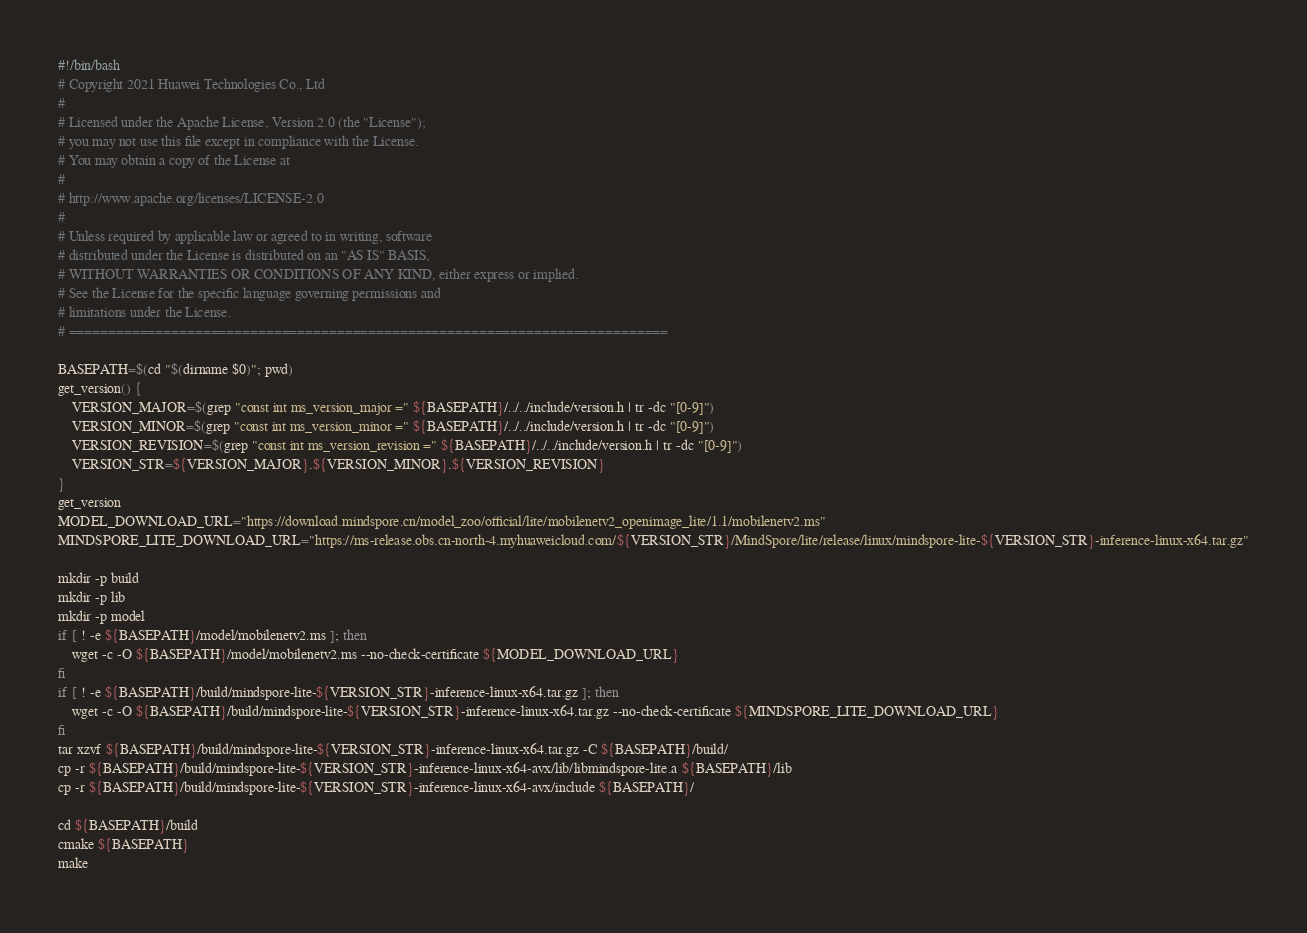<code> <loc_0><loc_0><loc_500><loc_500><_Bash_>#!/bin/bash
# Copyright 2021 Huawei Technologies Co., Ltd
#
# Licensed under the Apache License, Version 2.0 (the "License");
# you may not use this file except in compliance with the License.
# You may obtain a copy of the License at
#
# http://www.apache.org/licenses/LICENSE-2.0
#
# Unless required by applicable law or agreed to in writing, software
# distributed under the License is distributed on an "AS IS" BASIS,
# WITHOUT WARRANTIES OR CONDITIONS OF ANY KIND, either express or implied.
# See the License for the specific language governing permissions and
# limitations under the License.
# ============================================================================

BASEPATH=$(cd "$(dirname $0)"; pwd)
get_version() {
    VERSION_MAJOR=$(grep "const int ms_version_major =" ${BASEPATH}/../../include/version.h | tr -dc "[0-9]")
    VERSION_MINOR=$(grep "const int ms_version_minor =" ${BASEPATH}/../../include/version.h | tr -dc "[0-9]")
    VERSION_REVISION=$(grep "const int ms_version_revision =" ${BASEPATH}/../../include/version.h | tr -dc "[0-9]")
    VERSION_STR=${VERSION_MAJOR}.${VERSION_MINOR}.${VERSION_REVISION}
}
get_version
MODEL_DOWNLOAD_URL="https://download.mindspore.cn/model_zoo/official/lite/mobilenetv2_openimage_lite/1.1/mobilenetv2.ms"
MINDSPORE_LITE_DOWNLOAD_URL="https://ms-release.obs.cn-north-4.myhuaweicloud.com/${VERSION_STR}/MindSpore/lite/release/linux/mindspore-lite-${VERSION_STR}-inference-linux-x64.tar.gz"

mkdir -p build
mkdir -p lib
mkdir -p model
if [ ! -e ${BASEPATH}/model/mobilenetv2.ms ]; then
    wget -c -O ${BASEPATH}/model/mobilenetv2.ms --no-check-certificate ${MODEL_DOWNLOAD_URL}
fi
if [ ! -e ${BASEPATH}/build/mindspore-lite-${VERSION_STR}-inference-linux-x64.tar.gz ]; then
    wget -c -O ${BASEPATH}/build/mindspore-lite-${VERSION_STR}-inference-linux-x64.tar.gz --no-check-certificate ${MINDSPORE_LITE_DOWNLOAD_URL}
fi
tar xzvf ${BASEPATH}/build/mindspore-lite-${VERSION_STR}-inference-linux-x64.tar.gz -C ${BASEPATH}/build/
cp -r ${BASEPATH}/build/mindspore-lite-${VERSION_STR}-inference-linux-x64-avx/lib/libmindspore-lite.a ${BASEPATH}/lib
cp -r ${BASEPATH}/build/mindspore-lite-${VERSION_STR}-inference-linux-x64-avx/include ${BASEPATH}/

cd ${BASEPATH}/build
cmake ${BASEPATH}
make</code> 